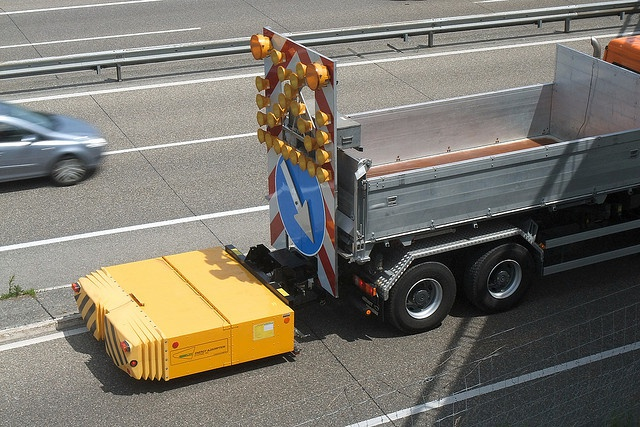Describe the objects in this image and their specific colors. I can see truck in darkgray, black, gray, and maroon tones and car in darkgray, gray, and black tones in this image. 